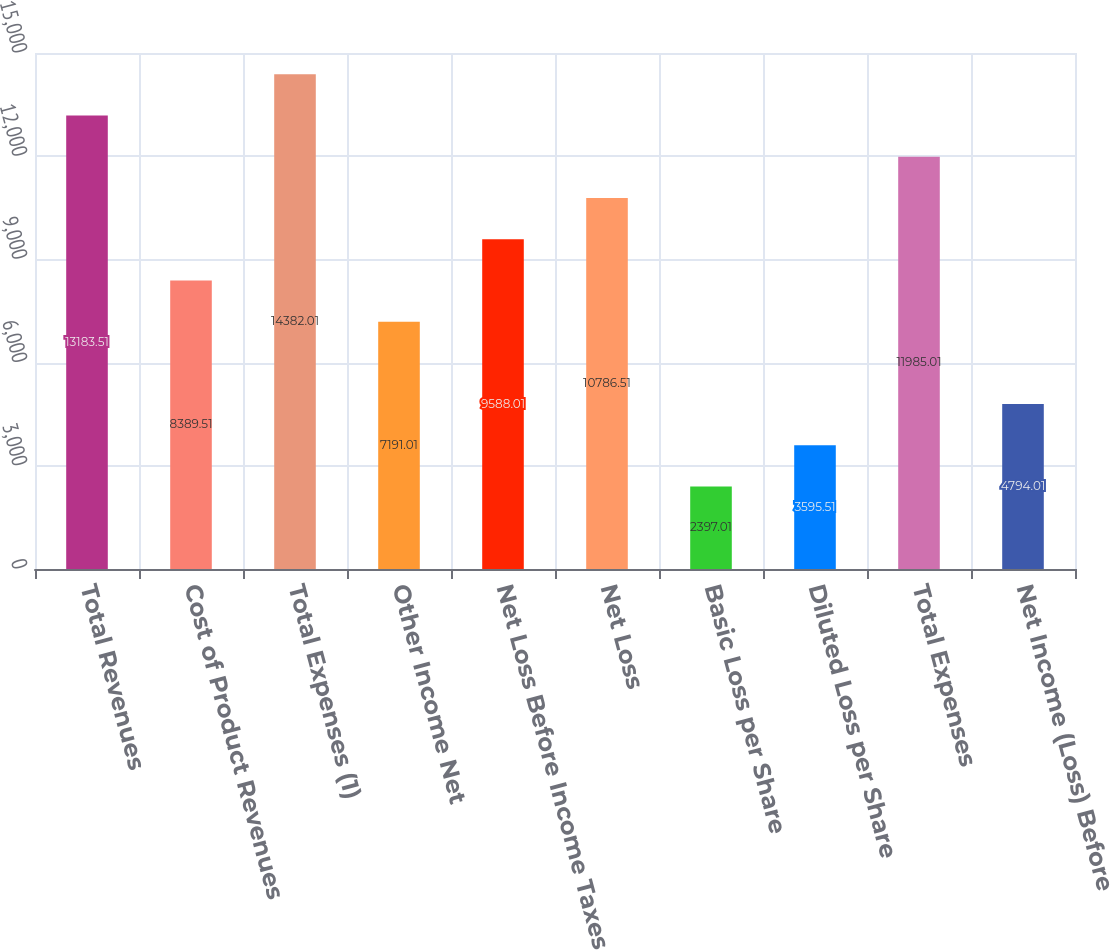Convert chart to OTSL. <chart><loc_0><loc_0><loc_500><loc_500><bar_chart><fcel>Total Revenues<fcel>Cost of Product Revenues<fcel>Total Expenses (1)<fcel>Other Income Net<fcel>Net Loss Before Income Taxes<fcel>Net Loss<fcel>Basic Loss per Share<fcel>Diluted Loss per Share<fcel>Total Expenses<fcel>Net Income (Loss) Before<nl><fcel>13183.5<fcel>8389.51<fcel>14382<fcel>7191.01<fcel>9588.01<fcel>10786.5<fcel>2397.01<fcel>3595.51<fcel>11985<fcel>4794.01<nl></chart> 